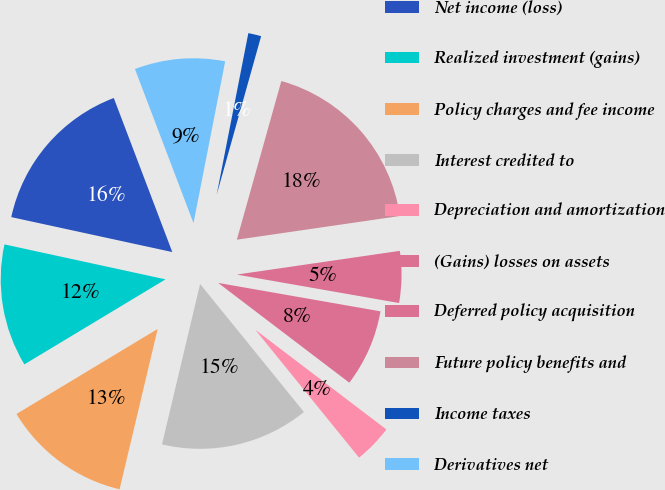Convert chart to OTSL. <chart><loc_0><loc_0><loc_500><loc_500><pie_chart><fcel>Net income (loss)<fcel>Realized investment (gains)<fcel>Policy charges and fee income<fcel>Interest credited to<fcel>Depreciation and amortization<fcel>(Gains) losses on assets<fcel>Deferred policy acquisition<fcel>Future policy benefits and<fcel>Income taxes<fcel>Derivatives net<nl><fcel>15.82%<fcel>12.03%<fcel>12.66%<fcel>14.56%<fcel>3.8%<fcel>7.59%<fcel>5.06%<fcel>18.35%<fcel>1.27%<fcel>8.86%<nl></chart> 